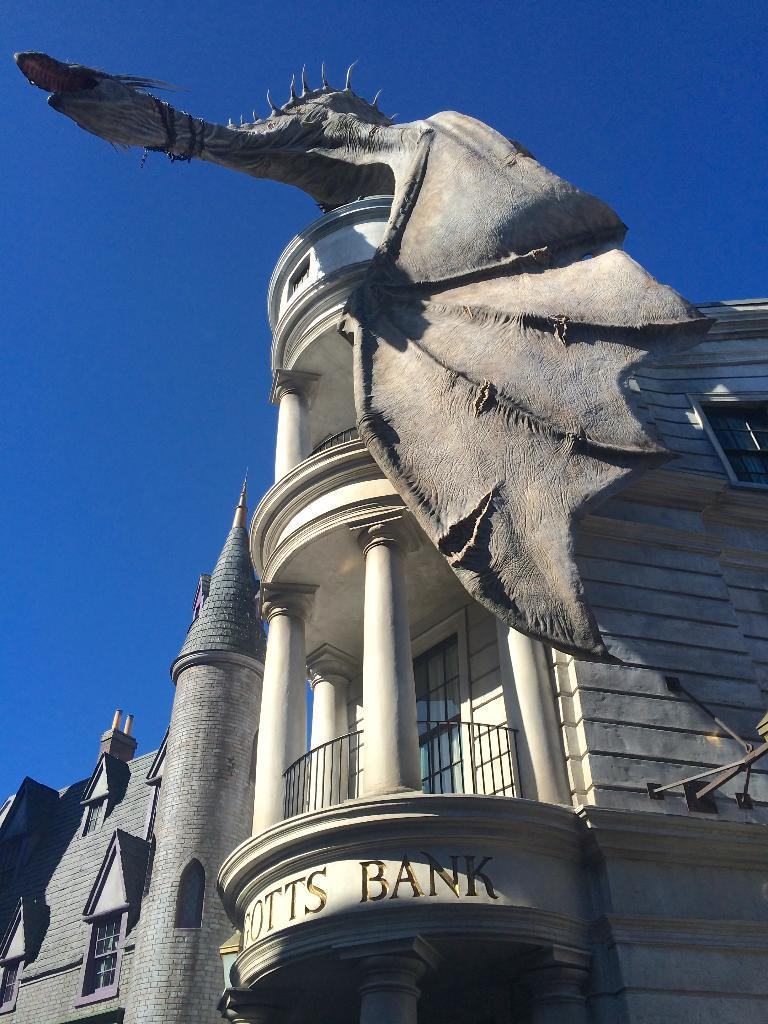What type of structures are present in the image? There are buildings with windows in the image. Can you describe any specific features of these buildings? Yes, there is a statue on top of one of the buildings in the image. What can be seen in the background of the image? The sky is visible in the background of the image. What type of songs can be heard playing from the statue in the image? There is no indication in the image that the statue is playing any songs, as statues are typically not capable of producing sound. 